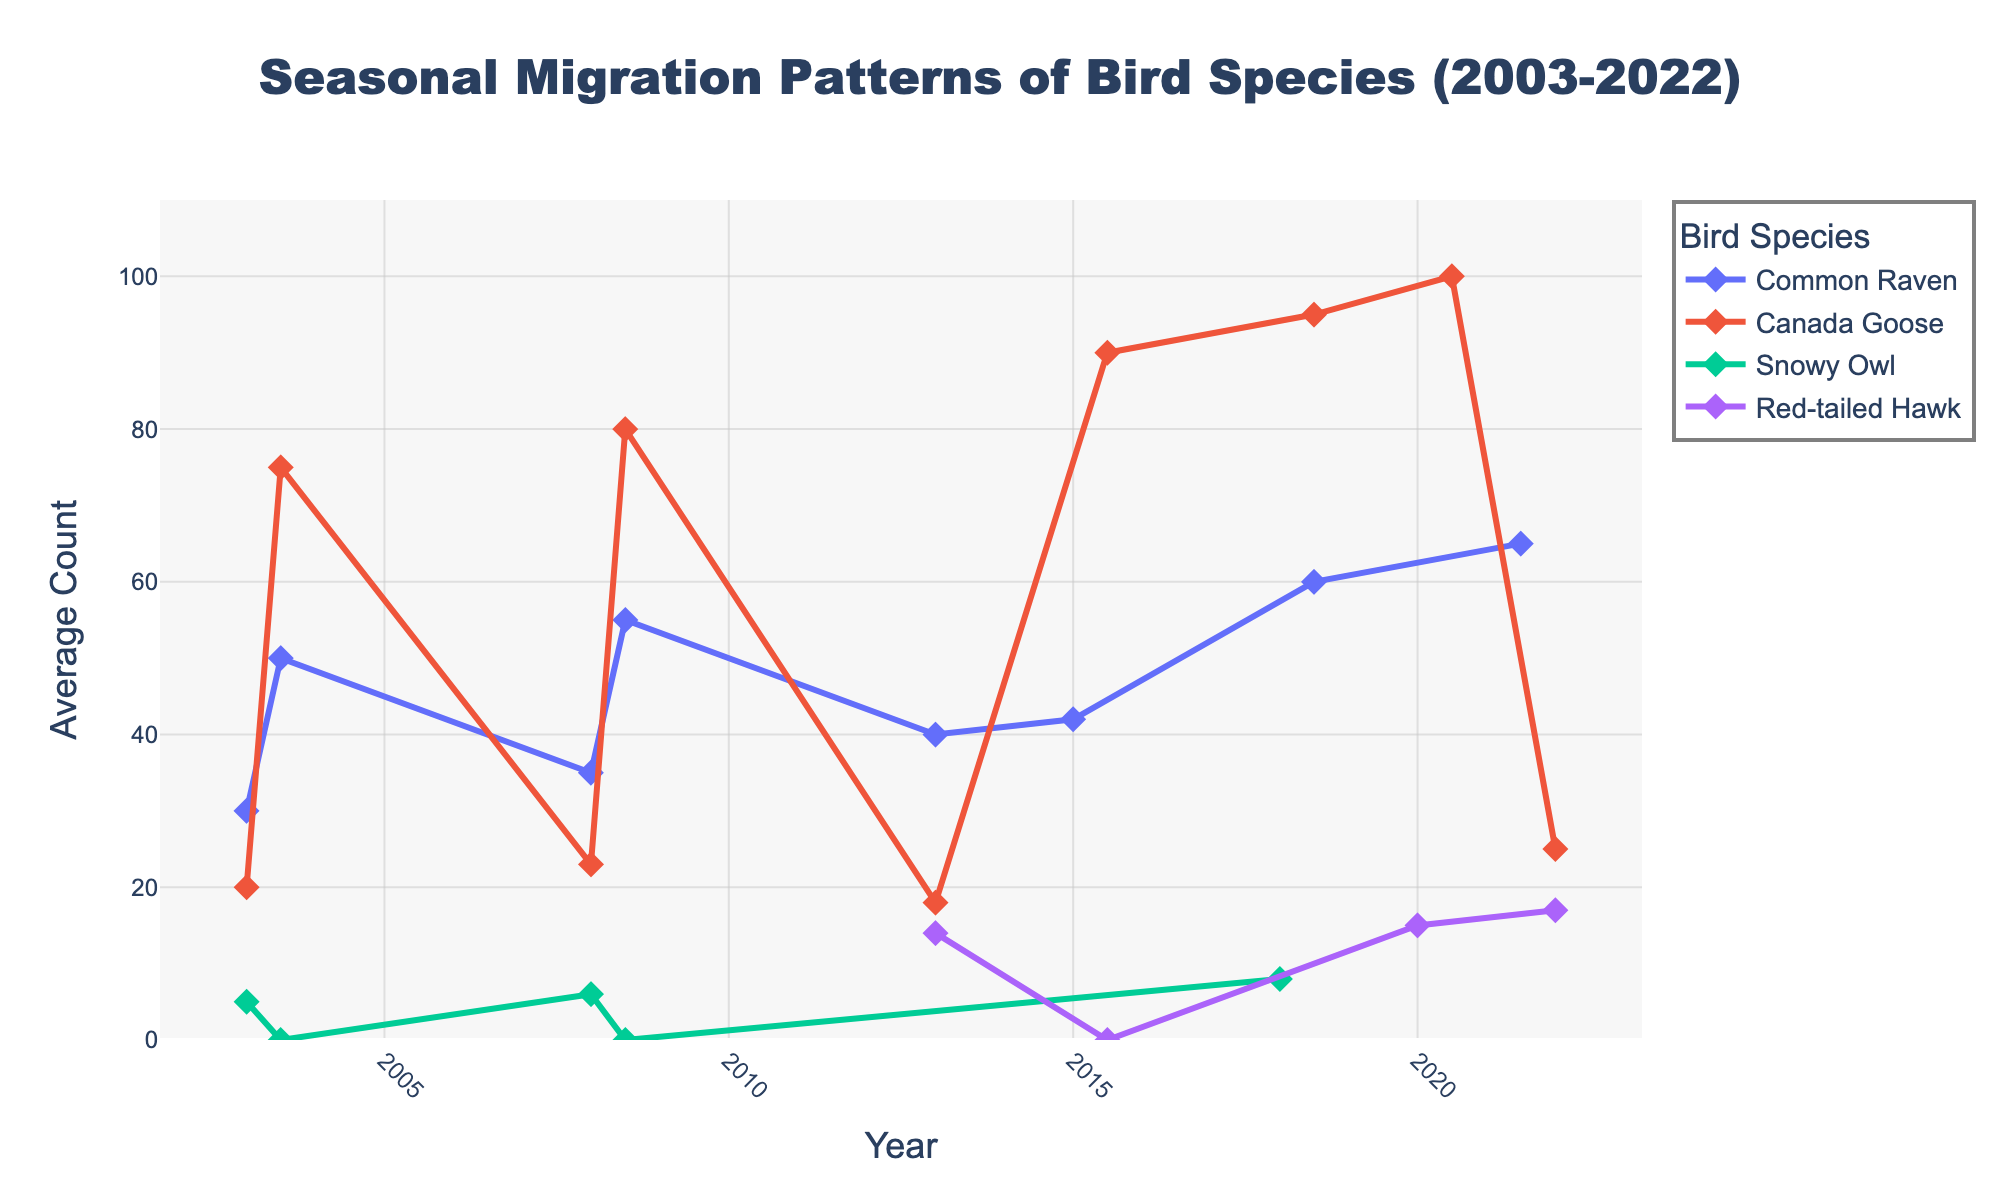What is the title of the figure? The title is located at the top center of the figure.
Answer: Seasonal Migration Patterns of Bird Species (2003-2022) What is the highest average count recorded for the Canada Goose and in what year and month did it occur? To find the highest point on the Canada Goose line, look for the peak value; it's marked on the y-axis and the corresponding date on the x-axis.
Answer: 100 in July 2020 Which species had the highest average count in January 2013? Locate the data points for January 2013 and compare the y-axis values for each species.
Answer: Common Raven How has the average count of the Common Raven changed from January 2003 to January 2022? Compare the average count at both January 2003 and January 2022 for the Common Raven. The values must be extracted and compared directly.
Answer: Increased What is the average count of Snowy Owls in January across all years? Sum all the January counts of Snowy Owls and divide by the number of January data points available.
Answer: (5 + 6 + 8) / 3 = 6.33 Which species showed a consistent presence in July across all observed years? Identify the species that have data points in all July observations in the plot.
Answer: Canada Goose Between 2003 and 2018, did the average count of birds tend to be higher in January or July? Compare the trend lines' general position and peaks in Januarys versus Julys across the years.
Answer: July Which bird species first appeared in the figure in January and in what year? Look for the first instance (leftmost point) of a new species in the time series.
Answer: Red-tailed Hawk in January 2013 Is there a species that went completely absent during any observed July in the plot? Examine each species' line in July and check for any instances where the count drops to zero.
Answer: Snowy Owl What pattern can be observed in the average count trend of Canada Goose from 2003 to 2022? Follow the Canada Goose trend line across the years, noting the direction and changes in magnitude over time.
Answer: Increasing trend 